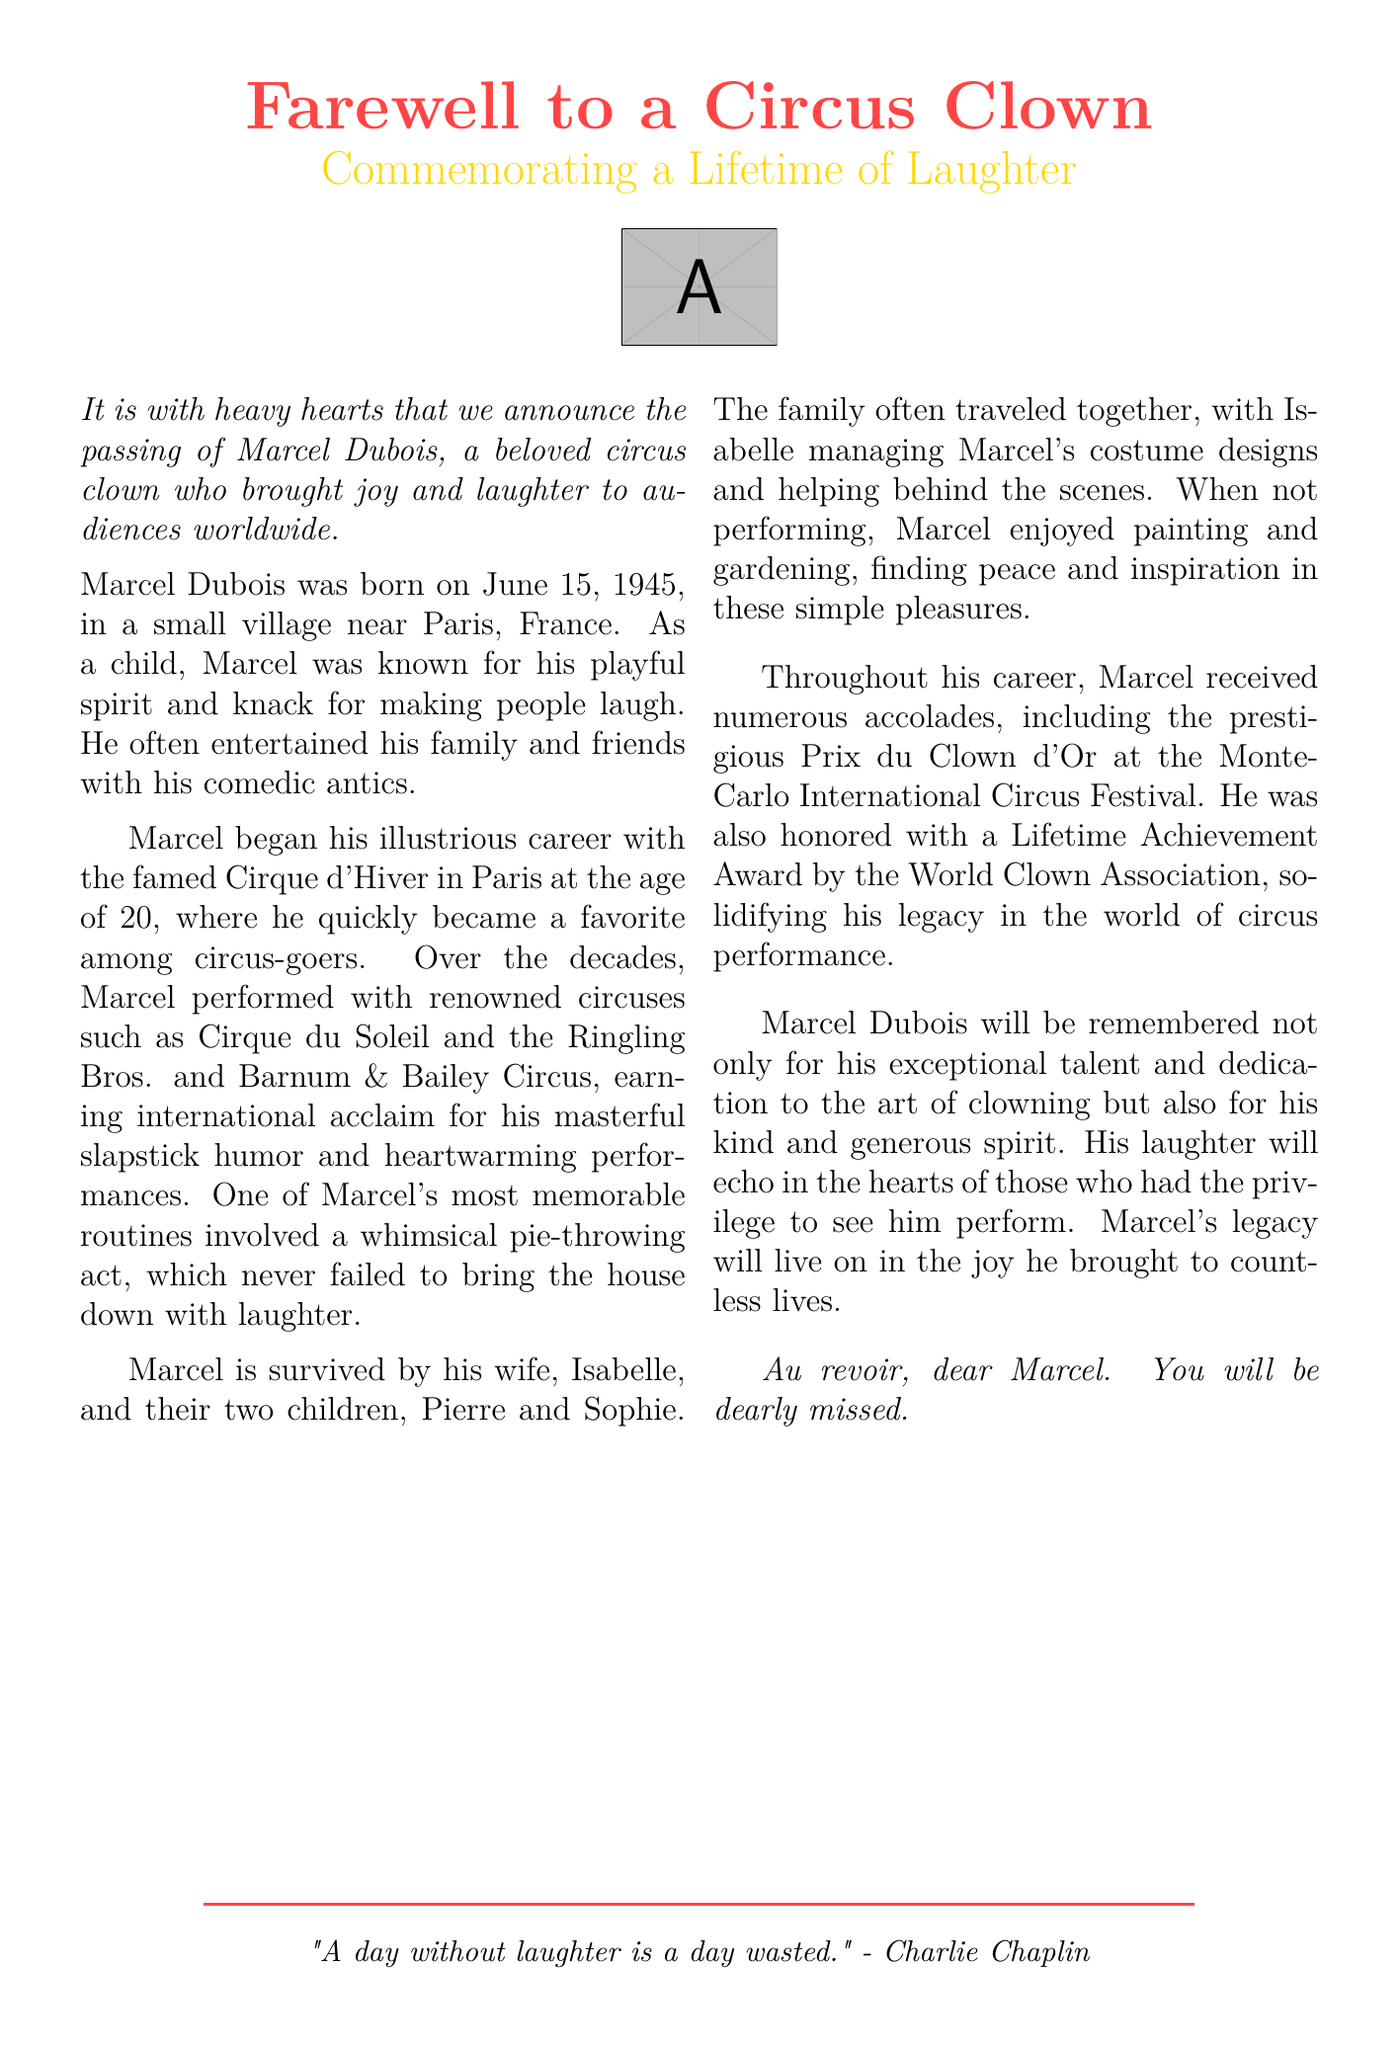What was the name of the circus clown? The document states the name of the clown as Marcel Dubois.
Answer: Marcel Dubois When was Marcel Dubois born? The text mentions Marcel Dubois's birth date as June 15, 1945.
Answer: June 15, 1945 What is one of Marcel's signature routines? The obituary highlights Marcel's whimsical pie-throwing act as memorable.
Answer: Pie-throwing act How many children did Marcel Dubois have? The document states that Marcel and Isabelle had two children.
Answer: Two children What significant award did Marcel receive at the Monte-Carlo International Circus Festival? The document mentions that Marcel received the Prix du Clown d'Or.
Answer: Prix du Clown d'Or What was Marcel's wife's name? The text indicates that Marcel's wife is named Isabelle.
Answer: Isabelle Which organizations did Marcel perform with? The document lists Cirque du Soleil and Ringling Bros. and Barnum & Bailey Circus as places he performed.
Answer: Cirque du Soleil, Ringling Bros. and Barnum & Bailey Circus What did Marcel Dubois enjoy doing besides performing? The obituary notes that he enjoyed painting and gardening in his spare time.
Answer: Painting and gardening What is the final sentiment expressed about Marcel? The document concludes with a heartfelt farewell expressing that he will be dearly missed.
Answer: You will be dearly missed 